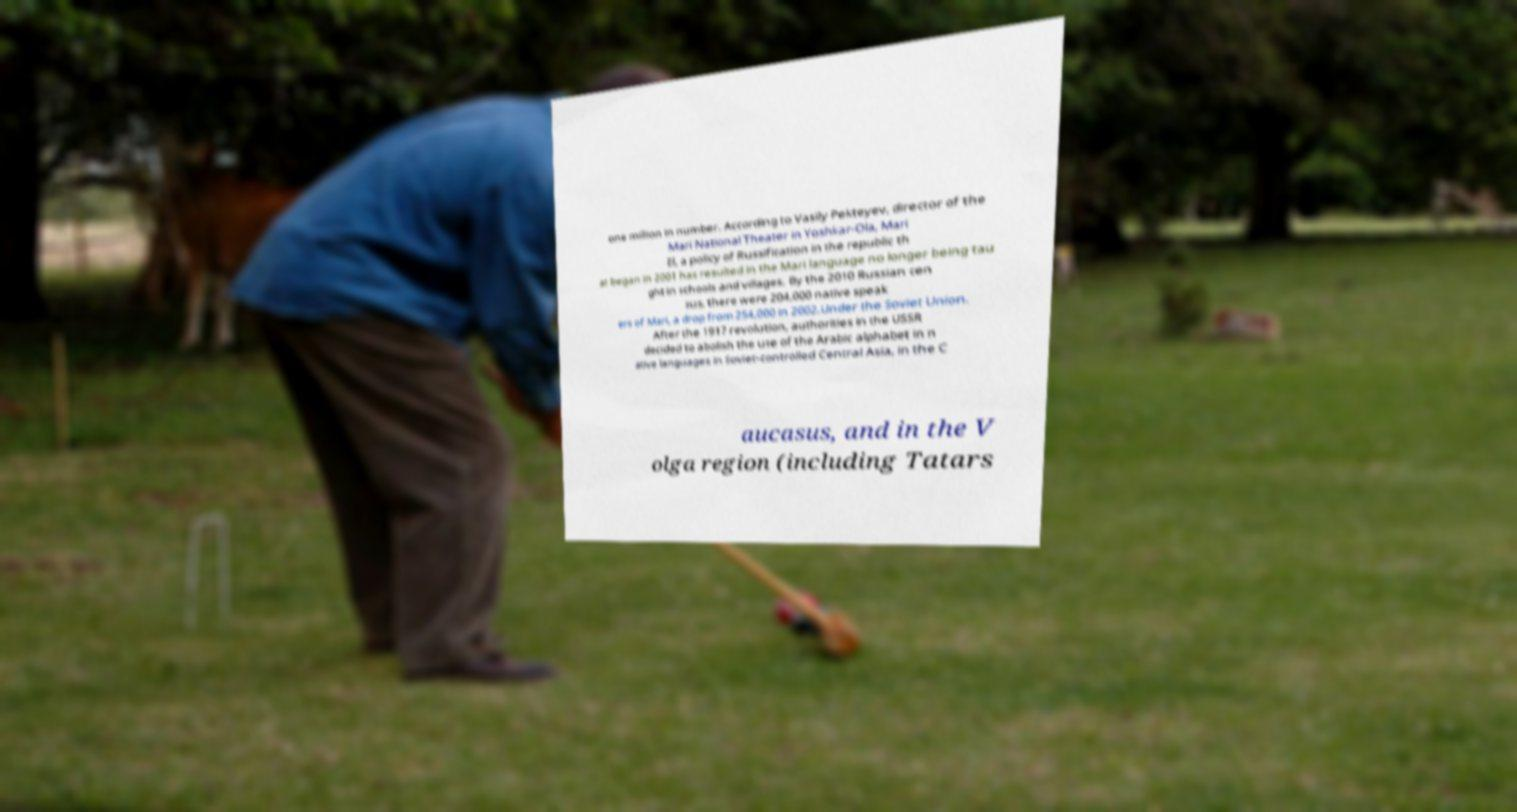I need the written content from this picture converted into text. Can you do that? one million in number. According to Vasily Pekteyev, director of the Mari National Theater in Yoshkar-Ola, Mari El, a policy of Russification in the republic th at began in 2001 has resulted in the Mari language no longer being tau ght in schools and villages. By the 2010 Russian cen sus, there were 204,000 native speak ers of Mari, a drop from 254,000 in 2002.Under the Soviet Union. After the 1917 revolution, authorities in the USSR decided to abolish the use of the Arabic alphabet in n ative languages in Soviet-controlled Central Asia, in the C aucasus, and in the V olga region (including Tatars 